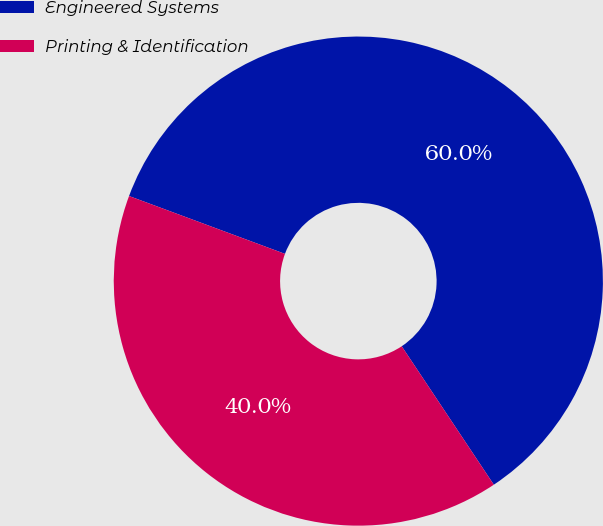Convert chart to OTSL. <chart><loc_0><loc_0><loc_500><loc_500><pie_chart><fcel>Engineered Systems<fcel>Printing & Identification<nl><fcel>60.0%<fcel>40.0%<nl></chart> 